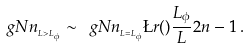Convert formula to latex. <formula><loc_0><loc_0><loc_500><loc_500>\ g N n _ { _ { L > L _ { \phi } } } \sim \ g N n _ { _ { L = L _ { \phi } } } \L r ( ) { \frac { L _ { \phi } } { L } } { 2 n - 1 } \, .</formula> 